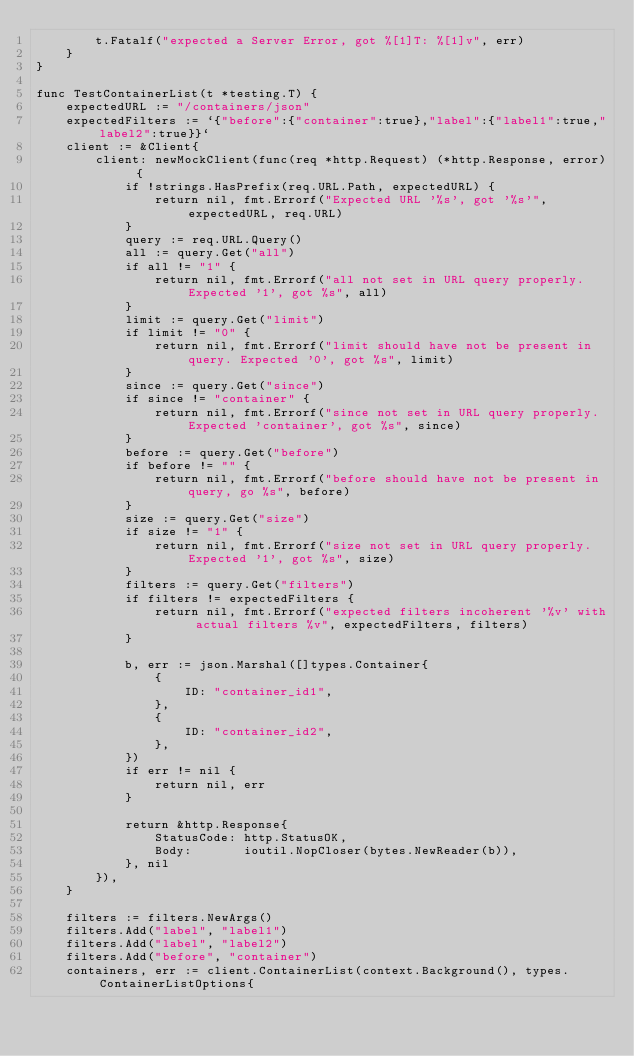Convert code to text. <code><loc_0><loc_0><loc_500><loc_500><_Go_>		t.Fatalf("expected a Server Error, got %[1]T: %[1]v", err)
	}
}

func TestContainerList(t *testing.T) {
	expectedURL := "/containers/json"
	expectedFilters := `{"before":{"container":true},"label":{"label1":true,"label2":true}}`
	client := &Client{
		client: newMockClient(func(req *http.Request) (*http.Response, error) {
			if !strings.HasPrefix(req.URL.Path, expectedURL) {
				return nil, fmt.Errorf("Expected URL '%s', got '%s'", expectedURL, req.URL)
			}
			query := req.URL.Query()
			all := query.Get("all")
			if all != "1" {
				return nil, fmt.Errorf("all not set in URL query properly. Expected '1', got %s", all)
			}
			limit := query.Get("limit")
			if limit != "0" {
				return nil, fmt.Errorf("limit should have not be present in query. Expected '0', got %s", limit)
			}
			since := query.Get("since")
			if since != "container" {
				return nil, fmt.Errorf("since not set in URL query properly. Expected 'container', got %s", since)
			}
			before := query.Get("before")
			if before != "" {
				return nil, fmt.Errorf("before should have not be present in query, go %s", before)
			}
			size := query.Get("size")
			if size != "1" {
				return nil, fmt.Errorf("size not set in URL query properly. Expected '1', got %s", size)
			}
			filters := query.Get("filters")
			if filters != expectedFilters {
				return nil, fmt.Errorf("expected filters incoherent '%v' with actual filters %v", expectedFilters, filters)
			}

			b, err := json.Marshal([]types.Container{
				{
					ID: "container_id1",
				},
				{
					ID: "container_id2",
				},
			})
			if err != nil {
				return nil, err
			}

			return &http.Response{
				StatusCode: http.StatusOK,
				Body:       ioutil.NopCloser(bytes.NewReader(b)),
			}, nil
		}),
	}

	filters := filters.NewArgs()
	filters.Add("label", "label1")
	filters.Add("label", "label2")
	filters.Add("before", "container")
	containers, err := client.ContainerList(context.Background(), types.ContainerListOptions{</code> 